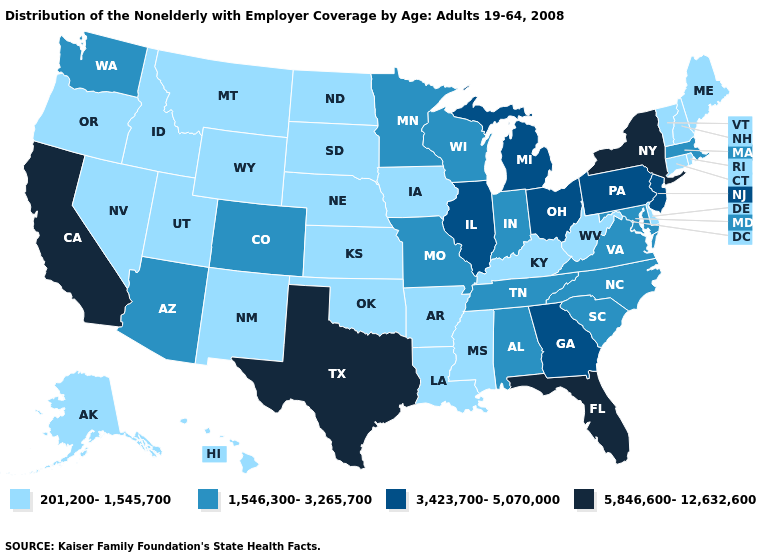What is the lowest value in the South?
Give a very brief answer. 201,200-1,545,700. Does the map have missing data?
Short answer required. No. What is the value of New Hampshire?
Keep it brief. 201,200-1,545,700. Does Ohio have a lower value than Florida?
Write a very short answer. Yes. Among the states that border Indiana , which have the lowest value?
Quick response, please. Kentucky. Among the states that border Minnesota , does North Dakota have the lowest value?
Quick response, please. Yes. Name the states that have a value in the range 201,200-1,545,700?
Give a very brief answer. Alaska, Arkansas, Connecticut, Delaware, Hawaii, Idaho, Iowa, Kansas, Kentucky, Louisiana, Maine, Mississippi, Montana, Nebraska, Nevada, New Hampshire, New Mexico, North Dakota, Oklahoma, Oregon, Rhode Island, South Dakota, Utah, Vermont, West Virginia, Wyoming. Name the states that have a value in the range 1,546,300-3,265,700?
Answer briefly. Alabama, Arizona, Colorado, Indiana, Maryland, Massachusetts, Minnesota, Missouri, North Carolina, South Carolina, Tennessee, Virginia, Washington, Wisconsin. What is the highest value in the Northeast ?
Keep it brief. 5,846,600-12,632,600. Which states have the lowest value in the Northeast?
Short answer required. Connecticut, Maine, New Hampshire, Rhode Island, Vermont. Among the states that border Pennsylvania , does Maryland have the lowest value?
Quick response, please. No. What is the highest value in the MidWest ?
Answer briefly. 3,423,700-5,070,000. Name the states that have a value in the range 5,846,600-12,632,600?
Be succinct. California, Florida, New York, Texas. What is the highest value in the USA?
Be succinct. 5,846,600-12,632,600. What is the highest value in the South ?
Quick response, please. 5,846,600-12,632,600. 